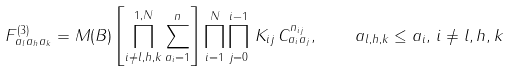<formula> <loc_0><loc_0><loc_500><loc_500>F ^ { ( 3 ) } _ { a _ { l } a _ { h } a _ { k } } = M ( B ) \left [ \prod _ { i \not = l , h , k } ^ { 1 , N } \sum _ { a _ { i } = 1 } ^ { n } \right ] \prod _ { i = 1 } ^ { N } \prod _ { j = 0 } ^ { i - 1 } \, K _ { i j } \, C _ { a _ { i } a _ { j } } ^ { n _ { i j } } , \quad a _ { l , h , k } \leq a _ { i } , \, i \not = l , h , k</formula> 